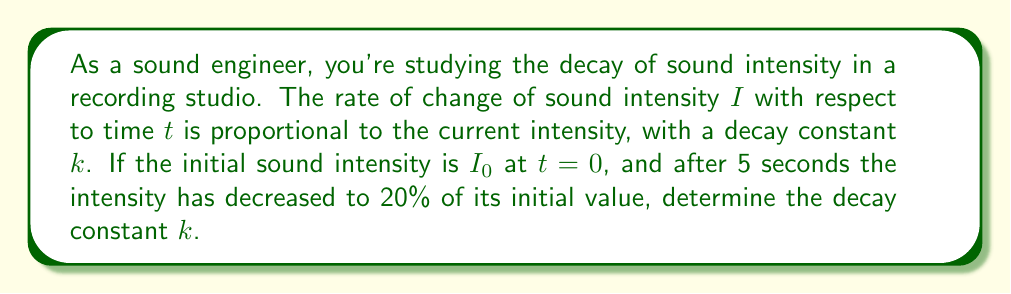Can you answer this question? 1) The differential equation modeling sound intensity decay is:

   $$\frac{dI}{dt} = -kI$$

   Where $k$ is the decay constant we need to find.

2) The solution to this differential equation is:

   $$I(t) = I_0e^{-kt}$$

   Where $I_0$ is the initial intensity at $t=0$.

3) We're told that after 5 seconds, the intensity is 20% of the initial value. Let's express this mathematically:

   $$I(5) = 0.2I_0$$

4) Substituting this into our solution equation:

   $$0.2I_0 = I_0e^{-k(5)}$$

5) Simplify by dividing both sides by $I_0$:

   $$0.2 = e^{-5k}$$

6) Take the natural log of both sides:

   $$\ln(0.2) = -5k$$

7) Solve for $k$:

   $$k = -\frac{\ln(0.2)}{5} \approx 0.3219$$
Answer: $k \approx 0.3219$ $s^{-1}$ 